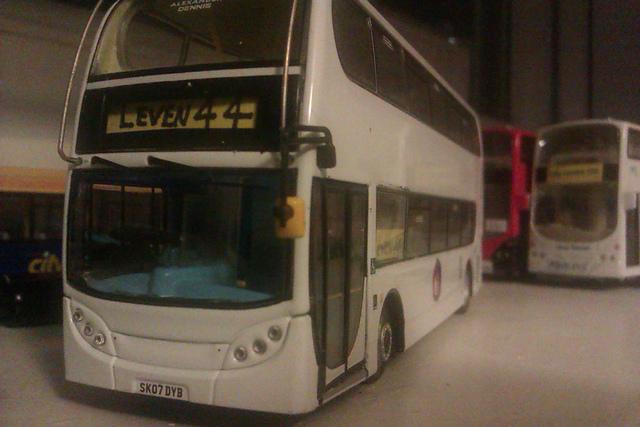Are all of the buses double decker?
Quick response, please. Yes. What no is on the bus?
Quick response, please. 44. What color is the bus?
Give a very brief answer. White. How many vehicles are pictured?
Answer briefly. 3. Are any of the vehicles moving?
Short answer required. No. 